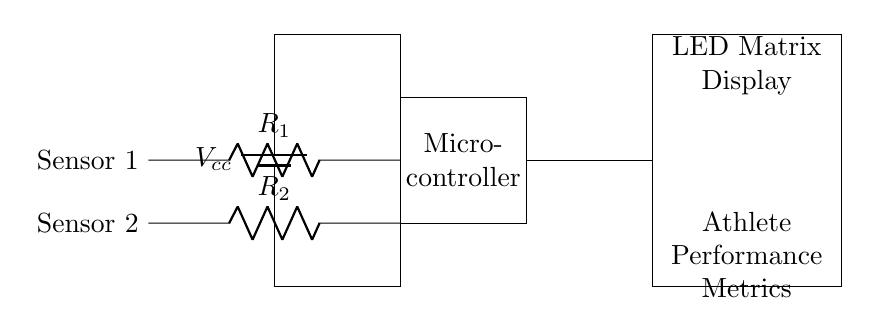What is the main component that processes data in this circuit? The main component that processes data in this circuit is the microcontroller, as it is typically responsible for interpreting input signals and controlling output based on that data.
Answer: microcontroller What type of display is used in this circuit? The display used in this circuit is an LED matrix display, which is indicated by the labeling in the diagram.
Answer: LED matrix display How many sensor inputs are present in the circuit? There are two sensor inputs shown in the circuit, labeled as Sensor 1 and Sensor 2, each connected through a resistor to the microcontroller.
Answer: two What does the circuit primarily measure? The circuit primarily measures athlete performance metrics, as denoted in the label near the LED matrix display.
Answer: athlete performance metrics What is the function of the resistors in the circuit? The resistors connect the sensors to the microcontroller, allowing them to adjust the signal levels that are fed into the microcontroller, which is essential for accurate measurements.
Answer: adjust signal levels Where does the power supply connect in the circuit? The power supply connects to the microcontroller at the top and influences the functioning of the entire circuit, as it provides the necessary voltage to operate the components.
Answer: microcontroller 